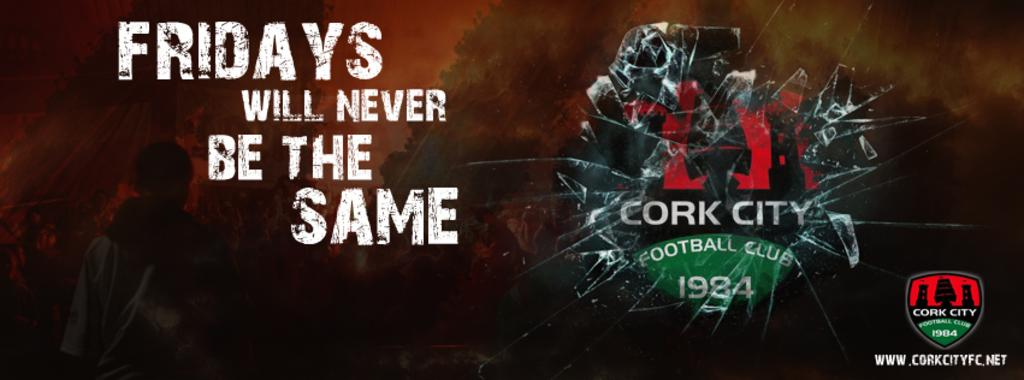Provide a one-sentence caption for the provided image. a FRIDAYS WILL NEVER BE THE SAME CORK CITY FOOTBALL CLUB 1984 ad. 